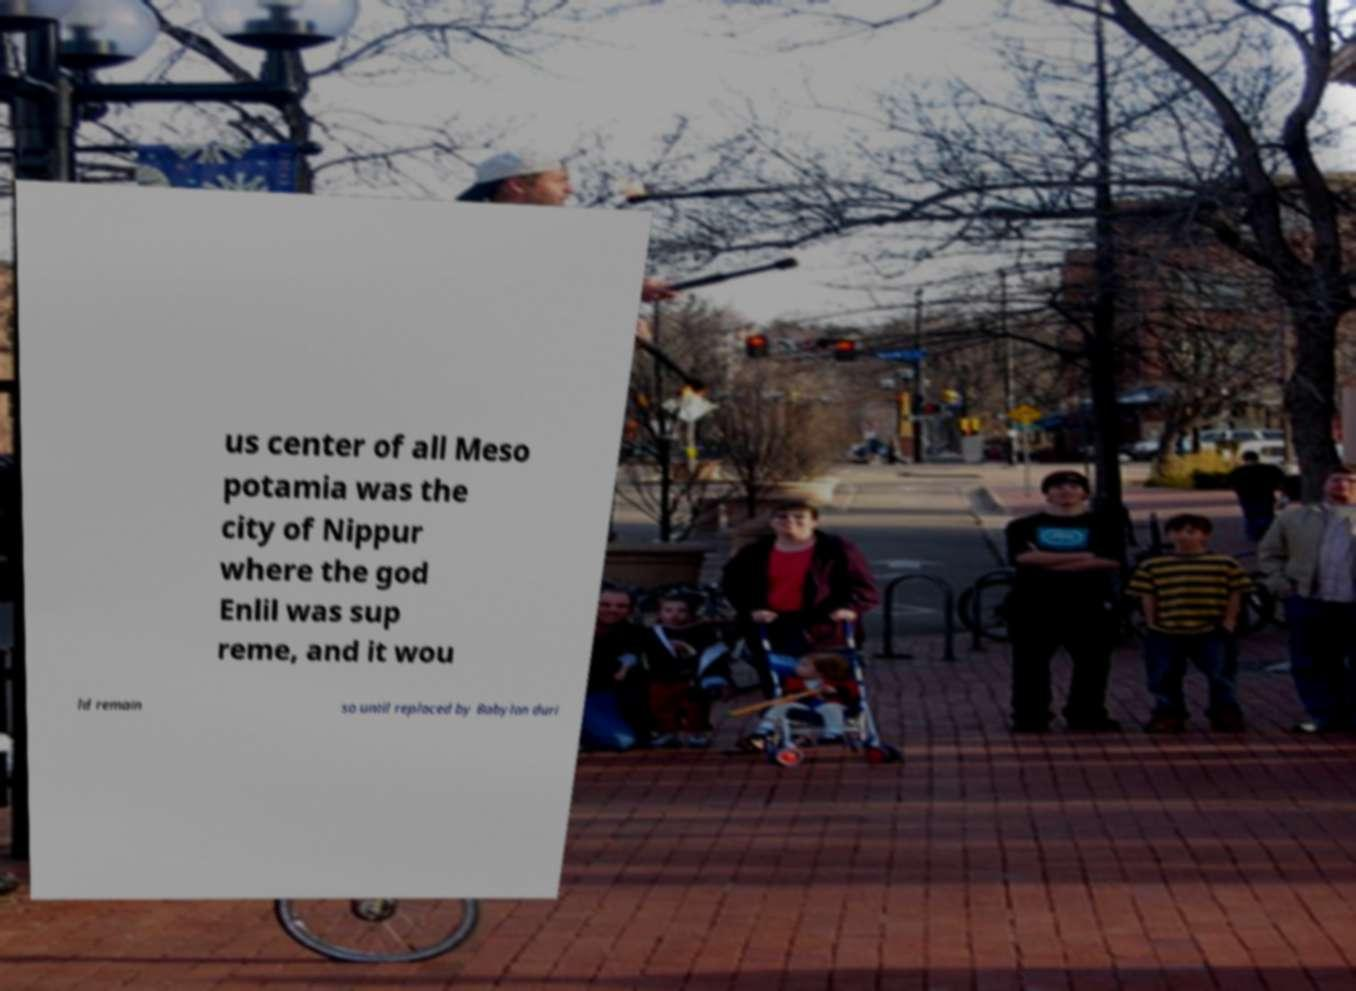Please read and relay the text visible in this image. What does it say? us center of all Meso potamia was the city of Nippur where the god Enlil was sup reme, and it wou ld remain so until replaced by Babylon duri 